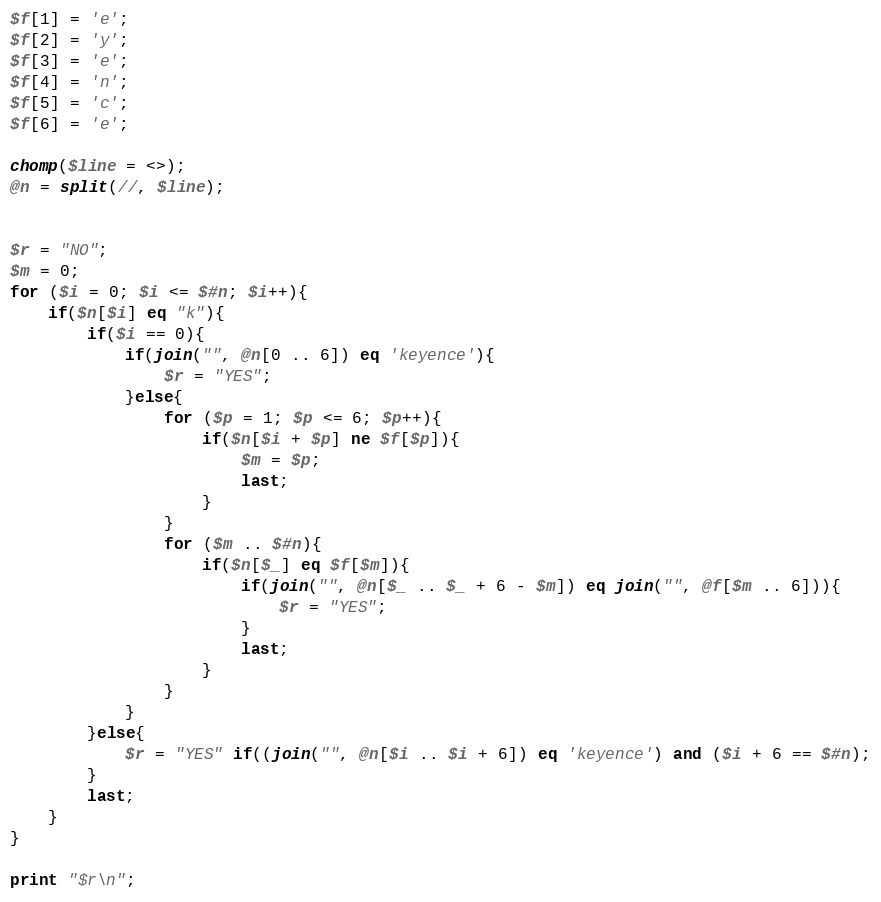Convert code to text. <code><loc_0><loc_0><loc_500><loc_500><_Perl_>$f[1] = 'e';
$f[2] = 'y';
$f[3] = 'e';
$f[4] = 'n';
$f[5] = 'c';
$f[6] = 'e';

chomp($line = <>);
@n = split(//, $line);


$r = "NO";
$m = 0;
for ($i = 0; $i <= $#n; $i++){
	if($n[$i] eq "k"){
		if($i == 0){
			if(join("", @n[0 .. 6]) eq 'keyence'){
				$r = "YES";
			}else{
				for ($p = 1; $p <= 6; $p++){
					if($n[$i + $p] ne $f[$p]){
						$m = $p;
						last;
					}
				}
				for ($m .. $#n){
					if($n[$_] eq $f[$m]){
						if(join("", @n[$_ .. $_ + 6 - $m]) eq join("", @f[$m .. 6])){
							$r = "YES";
						}
						last;
					}
				}
			}
		}else{
			$r = "YES" if((join("", @n[$i .. $i + 6]) eq 'keyence') and ($i + 6 == $#n);
		}
		last;
	}
}

print "$r\n";
</code> 